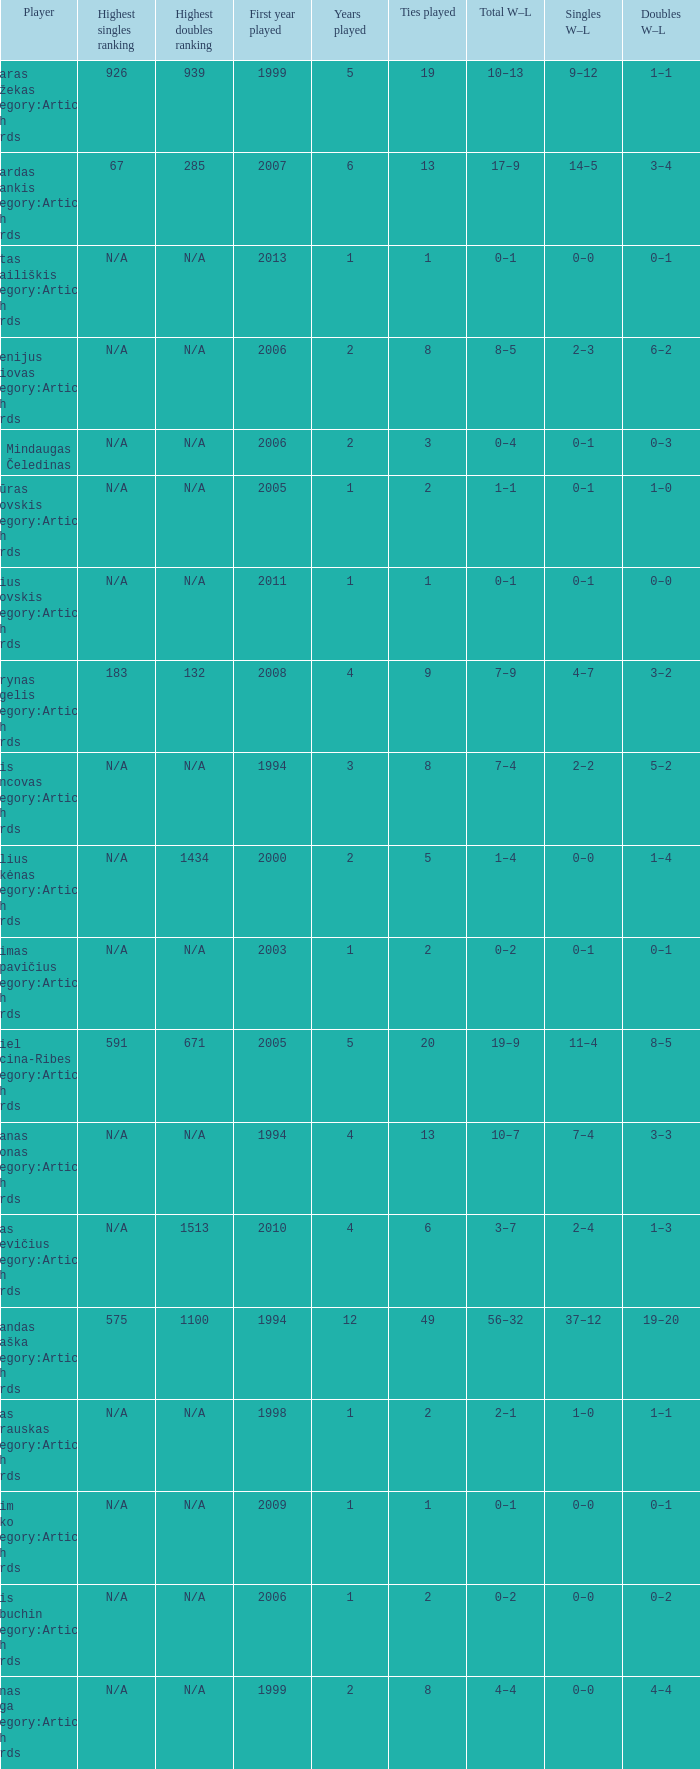What is the minimum number of ties played over a 6-year period? 13.0. Could you parse the entire table? {'header': ['Player', 'Highest singles ranking', 'Highest doubles ranking', 'First year played', 'Years played', 'Ties played', 'Total W–L', 'Singles W–L', 'Doubles W–L'], 'rows': [['Aivaras Balžekas Category:Articles with hCards', '926', '939', '1999', '5', '19', '10–13', '9–12', '1–1'], ['Ričardas Berankis Category:Articles with hCards', '67', '285', '2007', '6', '13', '17–9', '14–5', '3–4'], ['Mantas Bugailiškis Category:Articles with hCards', 'N/A', 'N/A', '2013', '1', '1', '0–1', '0–0', '0–1'], ['Eugenijus Cariovas Category:Articles with hCards', 'N/A', 'N/A', '2006', '2', '8', '8–5', '2–3', '6–2'], ['Mindaugas Čeledinas', 'N/A', 'N/A', '2006', '2', '3', '0–4', '0–1', '0–3'], ['Artūras Gotovskis Category:Articles with hCards', 'N/A', 'N/A', '2005', '1', '2', '1–1', '0–1', '1–0'], ['Julius Gotovskis Category:Articles with hCards', 'N/A', 'N/A', '2011', '1', '1', '0–1', '0–1', '0–0'], ['Laurynas Grigelis Category:Articles with hCards', '183', '132', '2008', '4', '9', '7–9', '4–7', '3–2'], ['Denis Ivancovas Category:Articles with hCards', 'N/A', 'N/A', '1994', '3', '8', '7–4', '2–2', '5–2'], ['Paulius Jurkėnas Category:Articles with hCards', 'N/A', '1434', '2000', '2', '5', '1–4', '0–0', '1–4'], ['Aurimas Karpavičius Category:Articles with hCards', 'N/A', 'N/A', '2003', '1', '2', '0–2', '0–1', '0–1'], ['Daniel Lencina-Ribes Category:Articles with hCards', '591', '671', '2005', '5', '20', '19–9', '11–4', '8–5'], ['Gitanas Mažonas Category:Articles with hCards', 'N/A', 'N/A', '1994', '4', '13', '10–7', '7–4', '3–3'], ['Lukas Mugevičius Category:Articles with hCards', 'N/A', '1513', '2010', '4', '6', '3–7', '2–4', '1–3'], ['Rolandas Muraška Category:Articles with hCards', '575', '1100', '1994', '12', '49', '56–32', '37–12', '19–20'], ['Tomas Petrauskas Category:Articles with hCards', 'N/A', 'N/A', '1998', '1', '2', '2–1', '1–0', '1–1'], ['Vadim Pinko Category:Articles with hCards', 'N/A', 'N/A', '2009', '1', '1', '0–1', '0–0', '0–1'], ['Denis Riabuchin Category:Articles with hCards', 'N/A', 'N/A', '2006', '1', '2', '0–2', '0–0', '0–2'], ['Arūnas Rozga Category:Articles with hCards', 'N/A', 'N/A', '1999', '2', '8', '4–4', '0–0', '4–4'], ['Gvidas Sabeckis Category:Articles with hCards', '488', '548', '2002', '8', '31', '23–21', '11–7', '12–14'], ['Dovydas Šakinis', '808', '1214', '2009', '5', '10', '4–8', '3–5', '1–3'], ['Aistis Šlajus', '1346', '1434', '1998', '3', '11', '6–10', '4–7', '2–3'], ['Julius Tverijonas Category:Articles with hCards', '1418', 'N/A', '2011', '1', '1', '0–1', '0–1', '0–0'], ['Giedrius Vėželis Category:Articles with hCards', 'N/A', 'N/A', '1994', '1', '3', '1–2', '1–0', '0–2']]} 